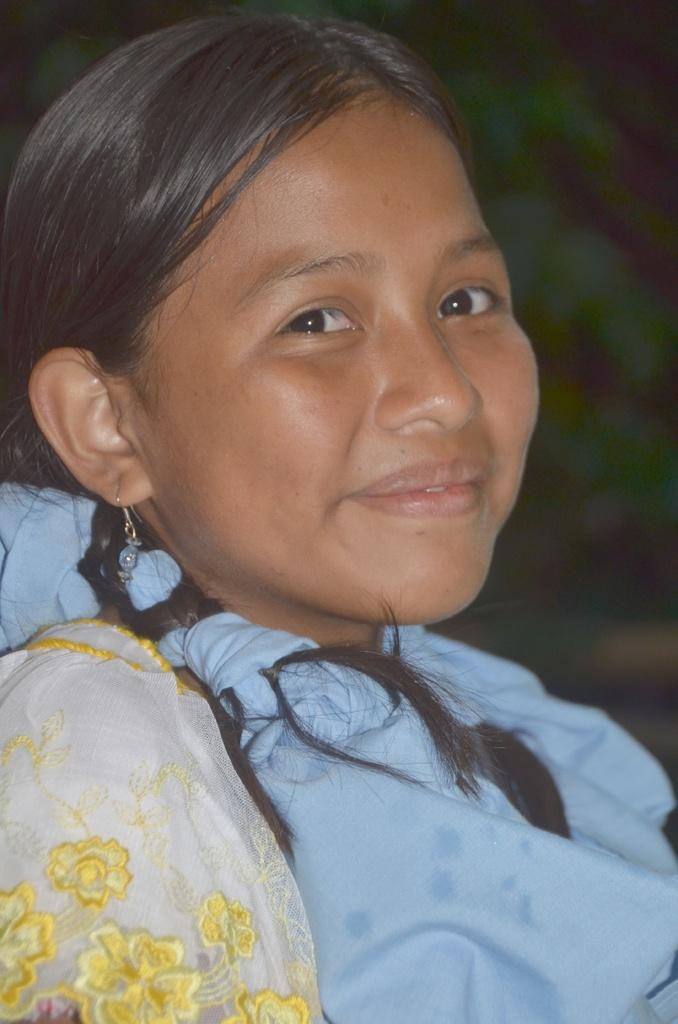Who is the main subject in the image? There is a girl in the image. What is the girl doing in the image? The girl is smiling in the image. Can you describe the background of the image? The background of the image is blurred. What type of rat can be seen in the image? There is no rat present in the image. What angle is the girl positioned at in the image? The angle at which the girl is positioned cannot be determined from the image alone, as it only shows her face and upper body. 